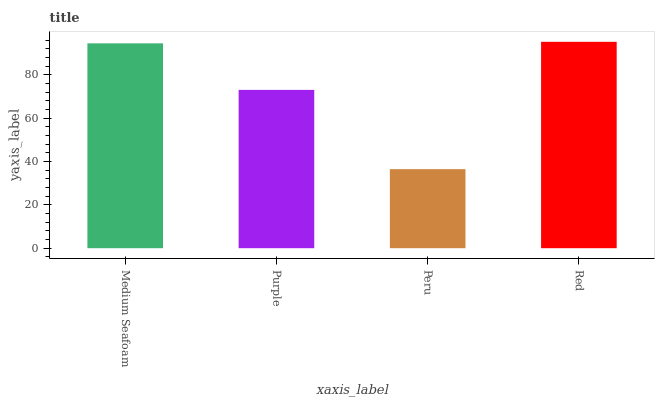Is Peru the minimum?
Answer yes or no. Yes. Is Red the maximum?
Answer yes or no. Yes. Is Purple the minimum?
Answer yes or no. No. Is Purple the maximum?
Answer yes or no. No. Is Medium Seafoam greater than Purple?
Answer yes or no. Yes. Is Purple less than Medium Seafoam?
Answer yes or no. Yes. Is Purple greater than Medium Seafoam?
Answer yes or no. No. Is Medium Seafoam less than Purple?
Answer yes or no. No. Is Medium Seafoam the high median?
Answer yes or no. Yes. Is Purple the low median?
Answer yes or no. Yes. Is Peru the high median?
Answer yes or no. No. Is Medium Seafoam the low median?
Answer yes or no. No. 